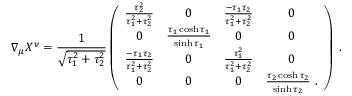<formula> <loc_0><loc_0><loc_500><loc_500>\nabla _ { \mu } X ^ { \nu } = \frac { 1 } { \sqrt { \tau _ { 1 } ^ { 2 } + \tau _ { 2 } ^ { 2 } } } \left ( \begin{array} { c c c c } { \frac { \tau _ { 2 } ^ { 2 } } { \tau _ { 1 } ^ { 2 } + \tau _ { 2 } ^ { 2 } } } & { 0 } & { \frac { - \tau _ { 1 } \tau _ { 2 } } { \tau _ { 1 } ^ { 2 } + \tau _ { 2 } ^ { 2 } } } & { 0 } \\ { 0 } & { \frac { \tau _ { 1 } \cosh \tau _ { 1 } } { \sinh \tau _ { 1 } } } & { 0 } & { 0 } \\ { \frac { - \tau _ { 1 } \tau _ { 2 } } { \tau _ { 1 } ^ { 2 } + \tau _ { 2 } ^ { 2 } } } & { 0 } & { \frac { \tau _ { 1 } ^ { 2 } } { \tau _ { 1 } ^ { 2 } + \tau _ { 2 } ^ { 2 } } } & { 0 } \\ { 0 } & { 0 } & { 0 } & { \frac { \tau _ { 2 } \cosh \tau _ { 2 } } { \sinh \tau _ { 2 } } \ . } \end{array} \right ) \ .</formula> 